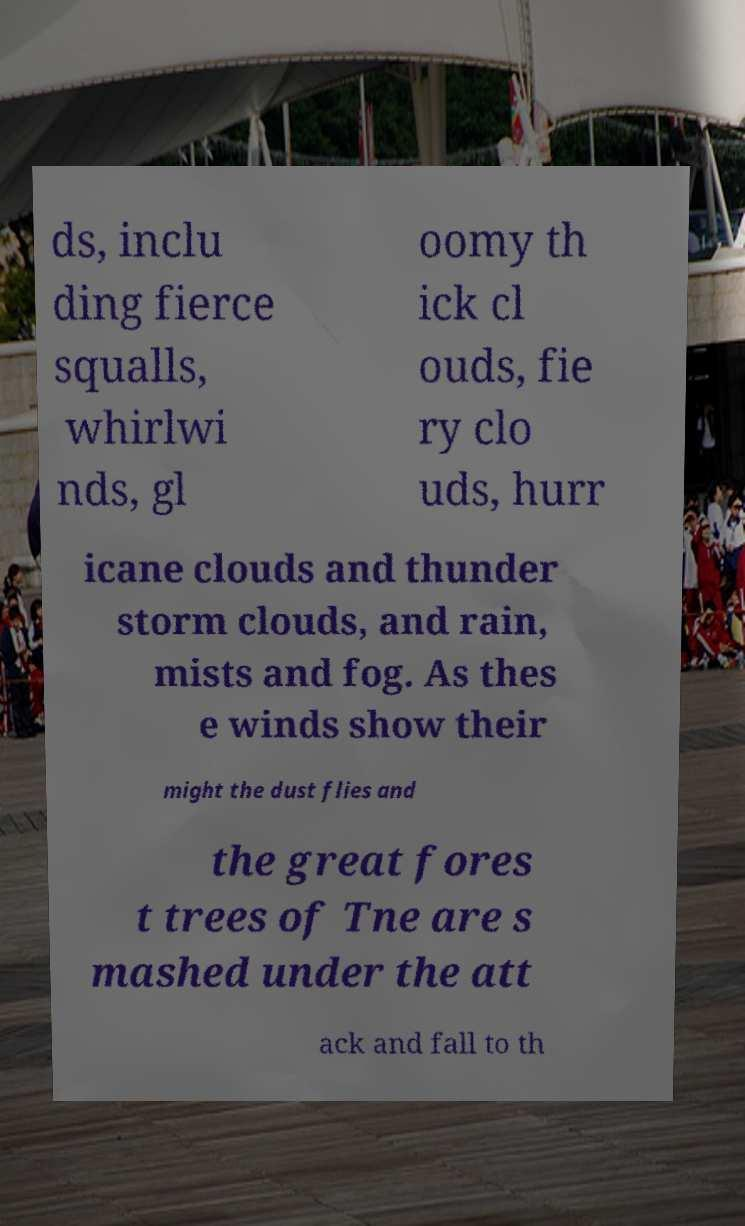I need the written content from this picture converted into text. Can you do that? ds, inclu ding fierce squalls, whirlwi nds, gl oomy th ick cl ouds, fie ry clo uds, hurr icane clouds and thunder storm clouds, and rain, mists and fog. As thes e winds show their might the dust flies and the great fores t trees of Tne are s mashed under the att ack and fall to th 